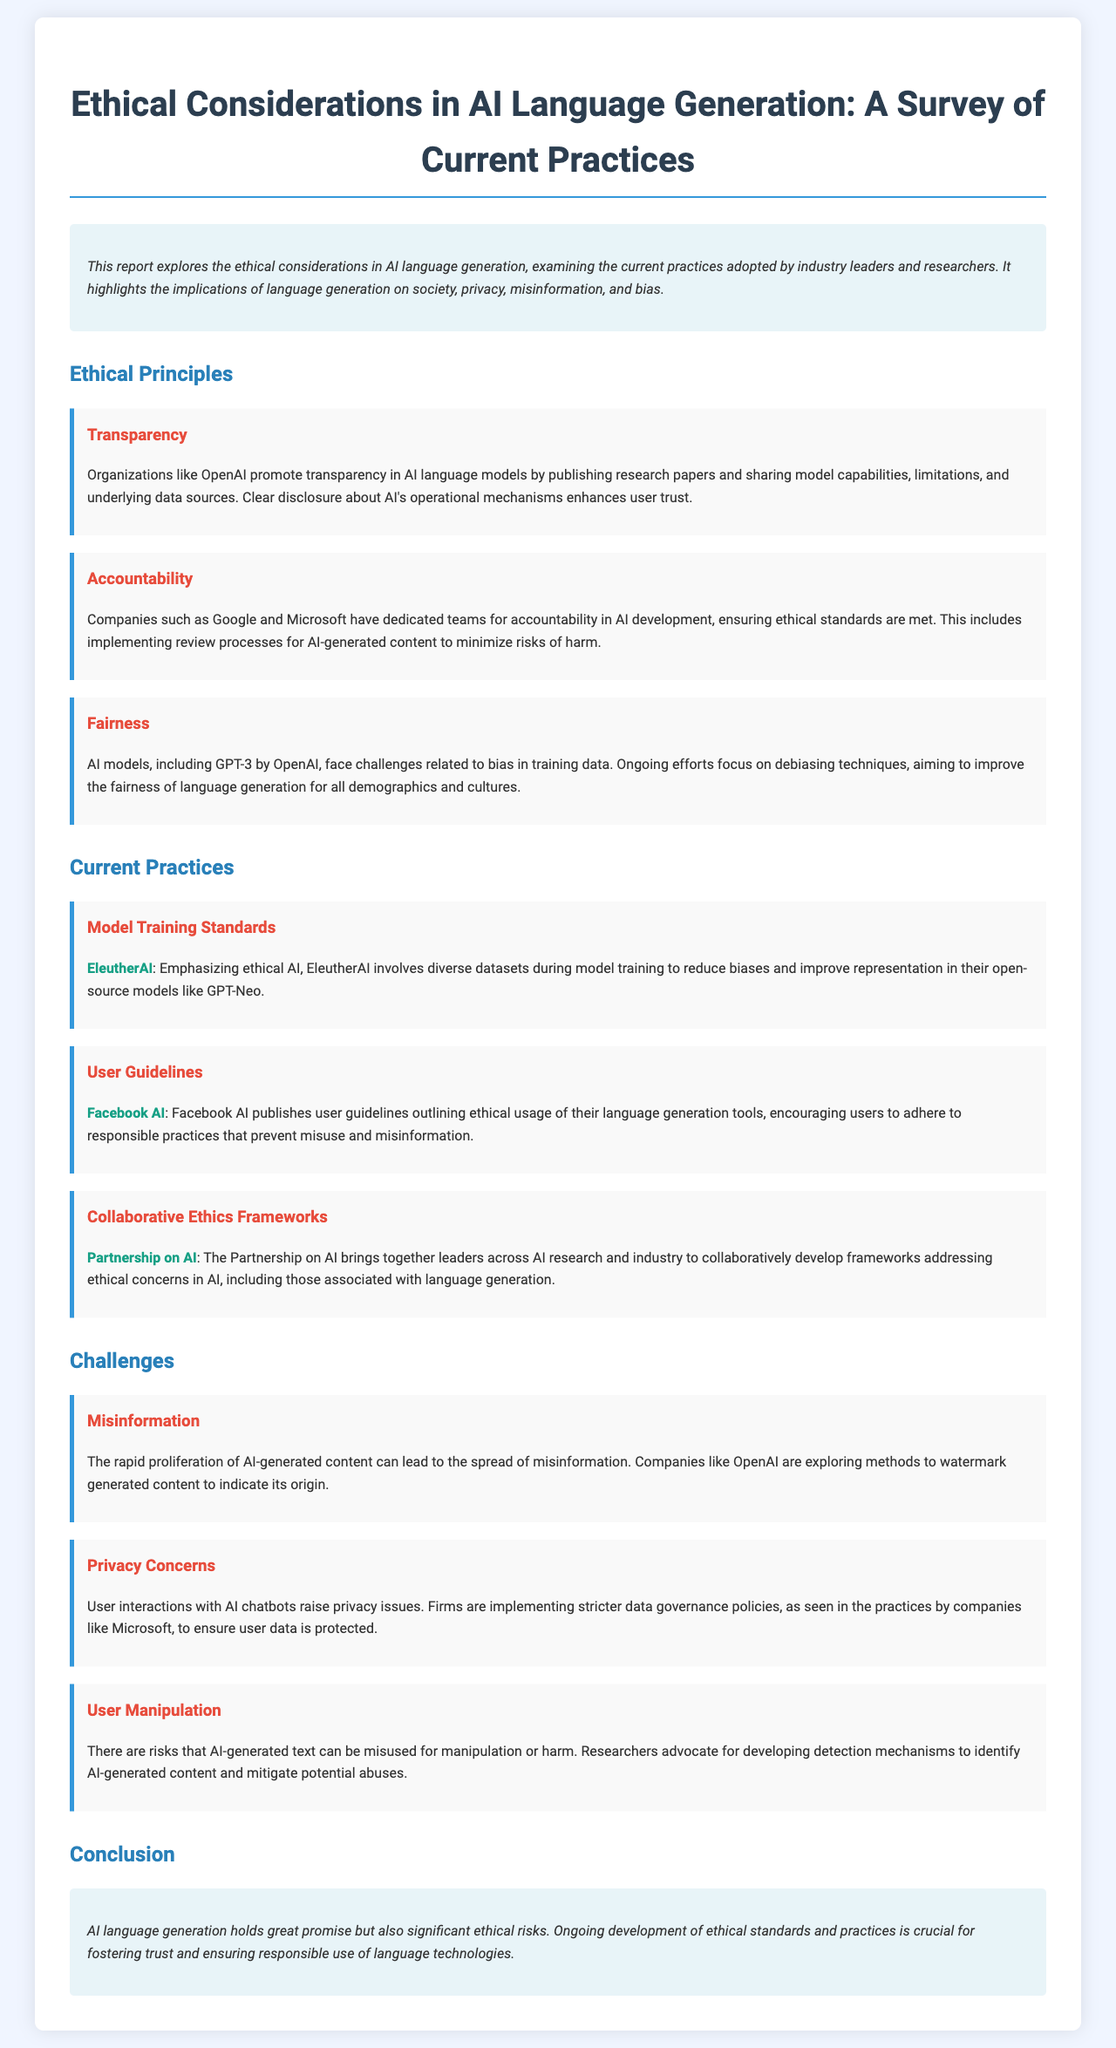What is the title of the report? The title of the report is provided at the beginning, summarizing the focus on ethical considerations in AI language generation.
Answer: Ethical Considerations in AI Language Generation: A Survey of Current Practices Which organization promotes transparency in AI language models? The document mentions OpenAI as an organization that promotes transparency in AI language models by publishing research papers.
Answer: OpenAI What ethical principle involves ensuring ethical standards are met? The ethical principle that involves ensuring ethical standards are met is referred to as accountability in the document.
Answer: Accountability Who emphasizes ethical AI using diverse datasets? EleutherAI is cited in the document as emphasizing ethical AI by involving diverse datasets during model training.
Answer: EleutherAI What is a challenge associated with AI-generated content? The document lists misinformation as one of the challenges related to AI-generated content that can lead to the spread of false information.
Answer: Misinformation What framework does Partnership on AI develop? The Partnership on AI develops collaborative ethics frameworks addressing ethical concerns in AI, including language generation.
Answer: Collaborative ethics frameworks Which company is mentioned as implementing stricter data governance policies? The document references Microsoft as a firm implementing stricter data governance policies to protect user data.
Answer: Microsoft What is a suggested method to indicate the origin of AI-generated content? The document states that companies like OpenAI are exploring methods to watermark generated content to indicate its origin.
Answer: Watermarking What is emphasized as crucial for fostering trust in AI language technologies? The conclusion highlights the ongoing development of ethical standards and practices as crucial for fostering trust in AI language technologies.
Answer: Ongoing development of ethical standards and practices 